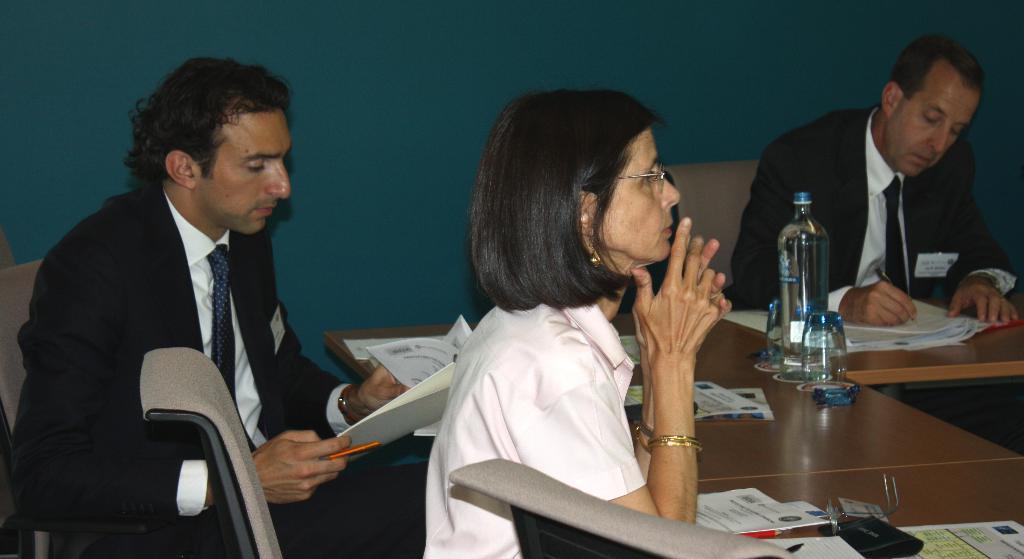Describe this image in one or two sentences. In this picture, we see a woman and two men are sitting on the chairs. The man on the left side is holding a pen and the papers in his hands. In front of them, we see a table on which pens, papers, glasses, water bottle and the books are placed. The man on the right side is holding a pen in his hand and he is writing something in the book. In the background, we see a wall in blue color. 